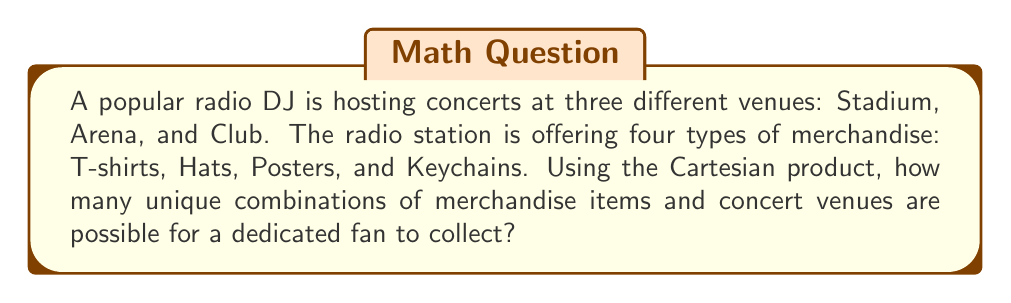Provide a solution to this math problem. To solve this problem, we need to use the concept of Cartesian product. The Cartesian product of two sets A and B, denoted as $A \times B$, is the set of all ordered pairs $(a,b)$ where $a \in A$ and $b \in B$.

Let's define our sets:
1. Set V (Venues) = {Stadium, Arena, Club}
2. Set M (Merchandise) = {T-shirts, Hats, Posters, Keychains}

We want to find $|V \times M|$, where $|\cdot|$ denotes the cardinality (number of elements) of a set.

The number of elements in a Cartesian product is equal to the product of the number of elements in each set:

$|V \times M| = |V| \cdot |M|$

We have:
$|V| = 3$ (number of venues)
$|M| = 4$ (number of merchandise items)

Therefore:

$|V \times M| = 3 \cdot 4 = 12$

This means there are 12 unique combinations of merchandise items and concert venues.

To list all combinations:

1. (Stadium, T-shirt)
2. (Stadium, Hat)
3. (Stadium, Poster)
4. (Stadium, Keychain)
5. (Arena, T-shirt)
6. (Arena, Hat)
7. (Arena, Poster)
8. (Arena, Keychain)
9. (Club, T-shirt)
10. (Club, Hat)
11. (Club, Poster)
12. (Club, Keychain)

Each of these combinations represents a unique opportunity for a dedicated fan to collect a specific merchandise item at a particular venue.
Answer: There are 12 unique combinations of merchandise items and concert venues. 